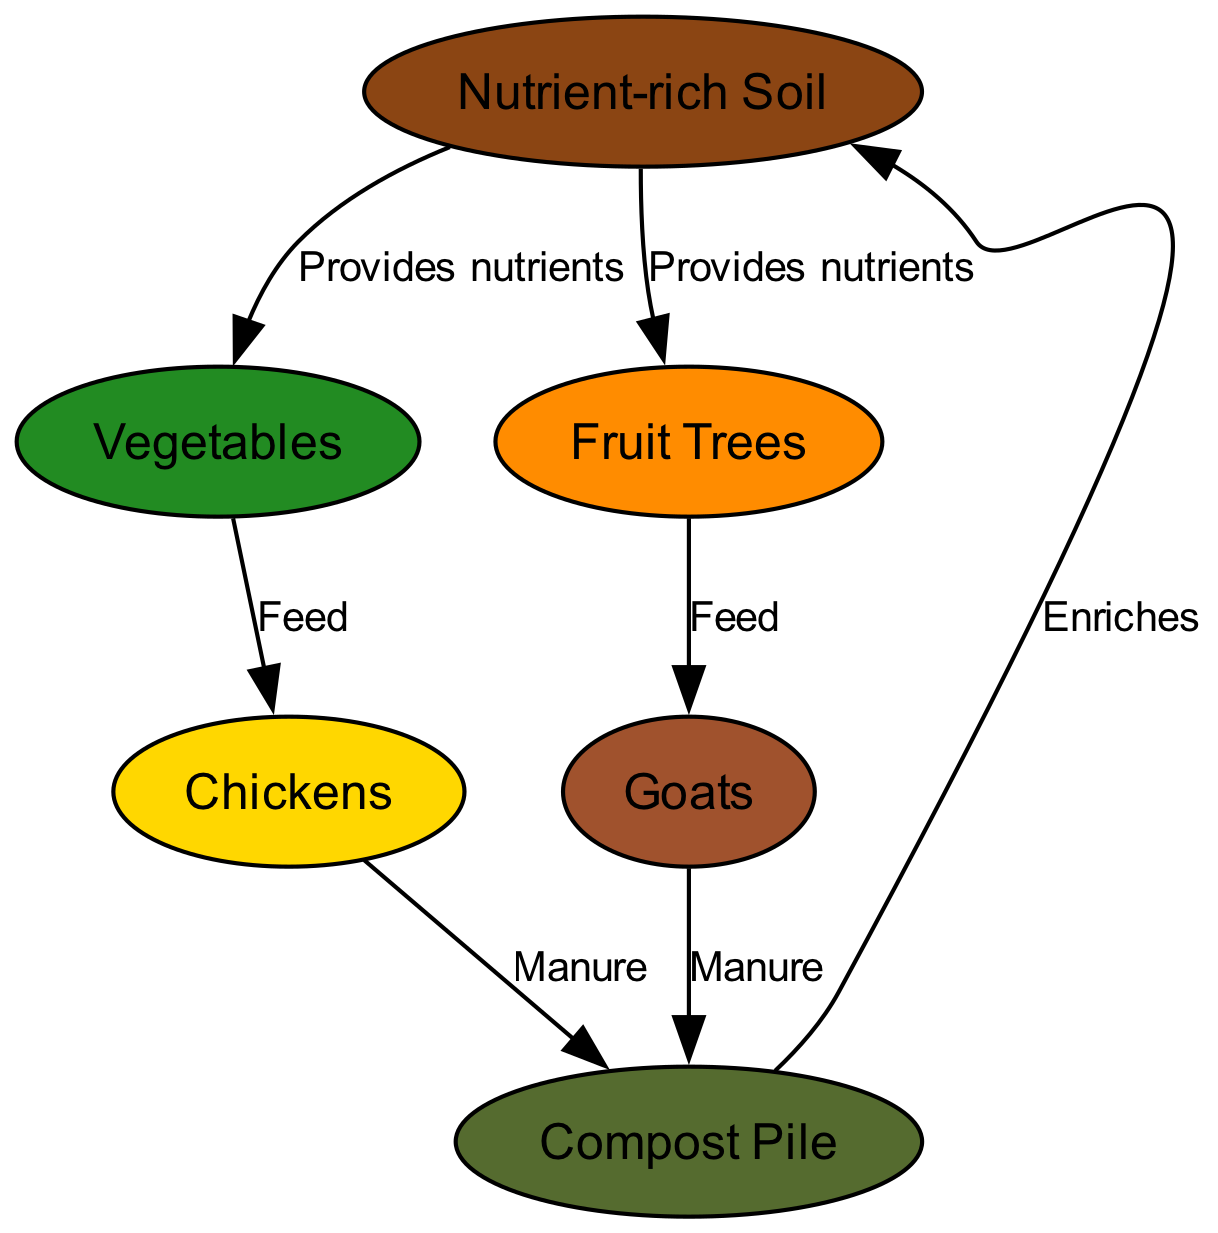What nodes are present in the diagram? The diagram includes six nodes: Nutrient-rich Soil, Compost Pile, Vegetables, Fruit Trees, Chickens, and Goats.
Answer: Six nodes What is the relationship between the soil and vegetables? The diagram shows that Nutrient-rich Soil provides nutrients to Vegetables.
Answer: Provides nutrients How many edges are there in the diagram? By counting the connections between the nodes, there are six edges.
Answer: Six edges Which animal is fed by vegetables? The diagram indicates that Chickens are fed by Vegetables.
Answer: Chickens What do goats receive as feed? According to the diagram, Goats receive feed from Fruit Trees.
Answer: Fruit Trees What is the end product of chickens and goats' manure? The manure from both Chickens and Goats is directed to the Compost Pile.
Answer: Compost Pile How does compost affect the soil? The diagram indicates that compost enriches the Nutrient-rich Soil.
Answer: Enriches Which two plants receive nutrients directly from the soil? Both Vegetables and Fruit Trees receive nutrients directly from Nutrient-rich Soil.
Answer: Vegetables and Fruit Trees What contributes to the compost pile? The nutrients from the manure of both Chickens and Goats contribute to the Compost Pile.
Answer: Manure 